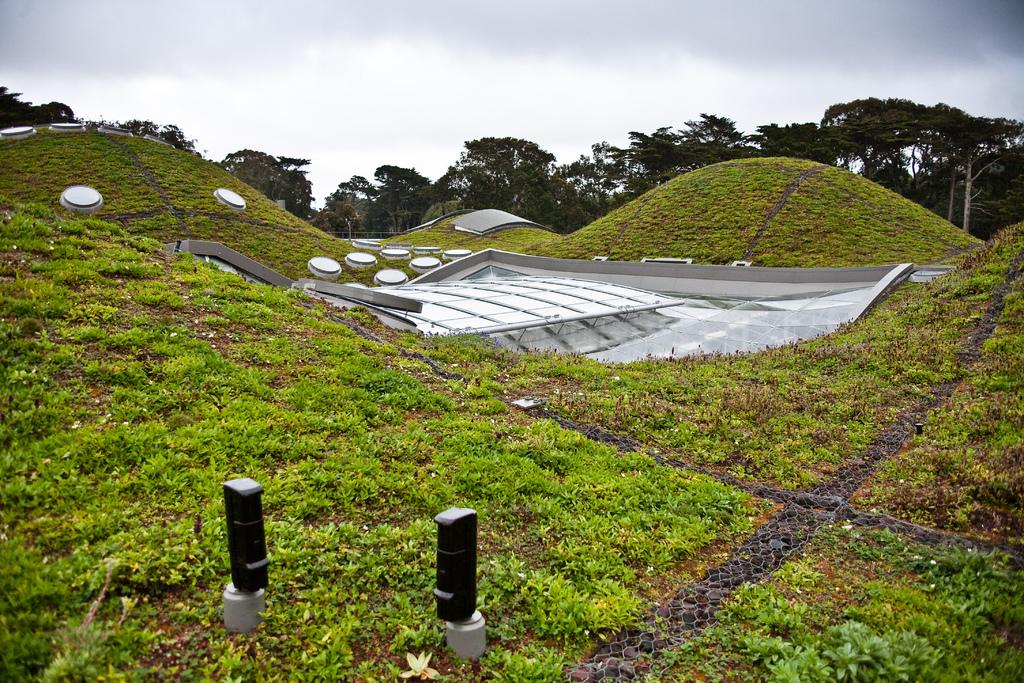What is the main object in the middle of the image? There is a glass object in the middle of the image. What type of natural scenery can be seen in the image? There are trees visible in the image. How would you describe the weather based on the sky in the image? The sky is cloudy in the image, suggesting overcast or potentially rainy weather. What type of soup is being served in the glass object in the image? There is no soup present in the image; the main object is a glass object, not a container for soup. 